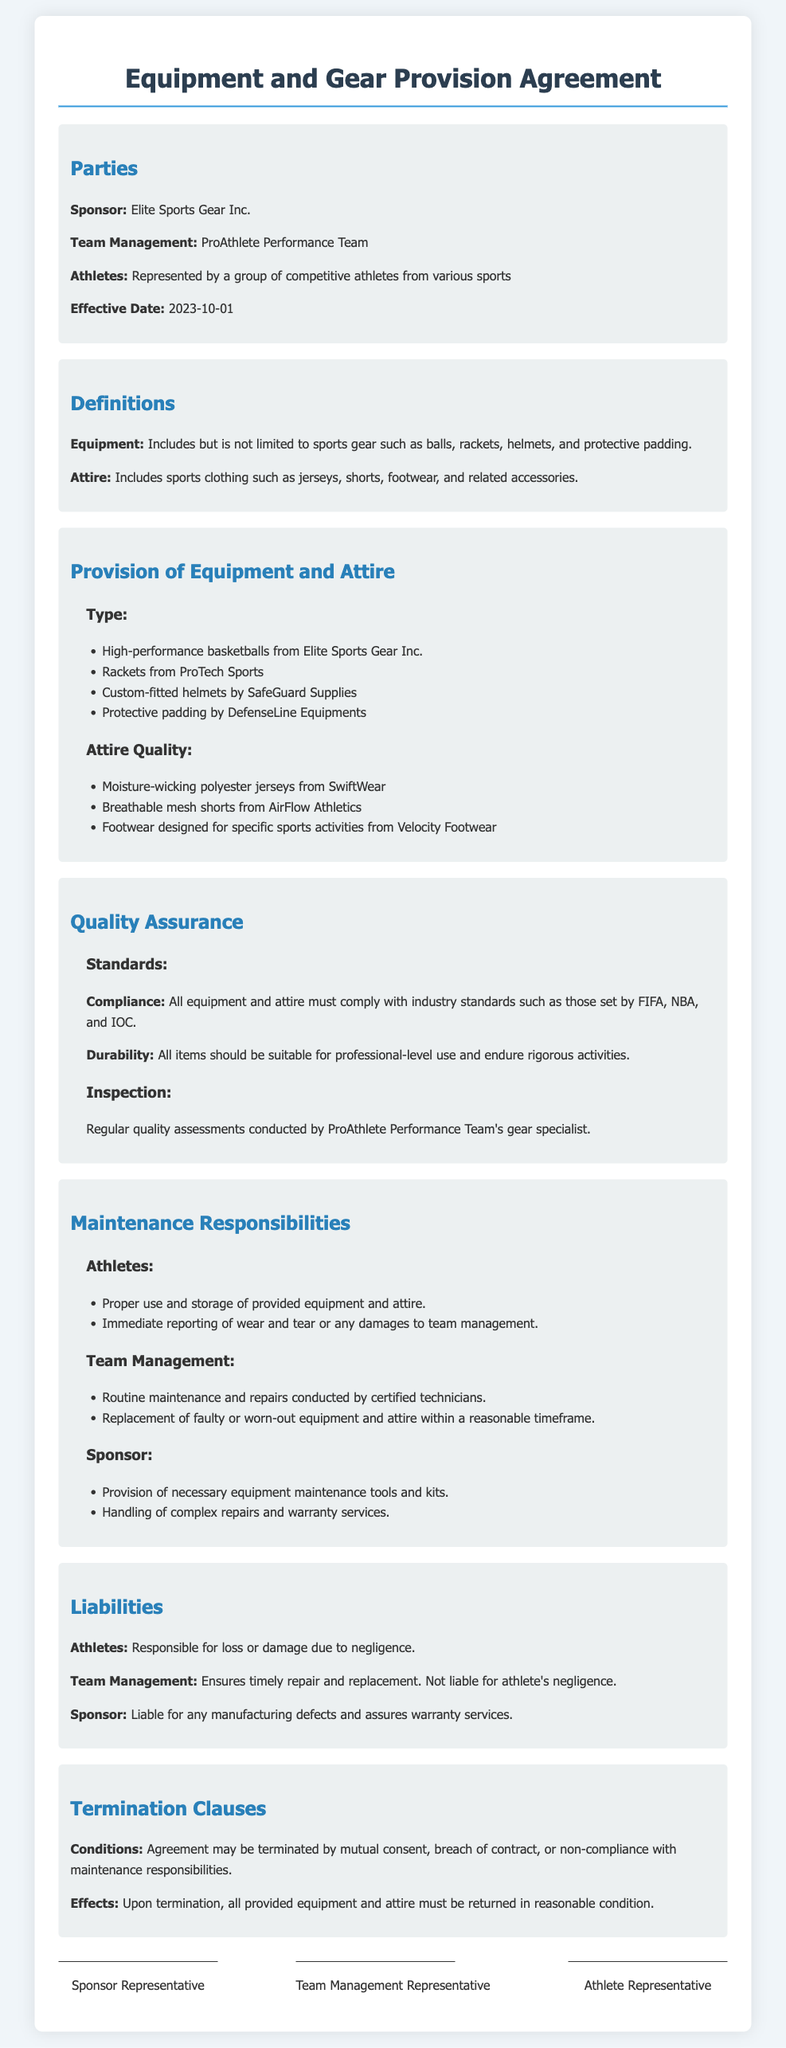What is the name of the sponsor? The name of the sponsor is mentioned in the Parties section of the document.
Answer: Elite Sports Gear Inc What date is the agreement effective from? The effective date is specified in the Parties section of the document.
Answer: 2023-10-01 What type of attire is included as per the document? The types of attire are listed in the Provision of Equipment and Attire section.
Answer: Jerseys, shorts, footwear What is the primary responsibility of athletes regarding equipment? The document specifies the responsibilities of athletes in the Maintenance Responsibilities section.
Answer: Proper use and storage Who is responsible for complex repairs? The obligations of the sponsor regarding repairs are mentioned in the Maintenance Responsibilities section.
Answer: Sponsor What must happen to the equipment upon termination of the agreement? The conditions regarding equipment return are detailed in the Termination Clauses section.
Answer: Returned in reasonable condition What standards must equipment and attire comply with? The requirements for compliance are listed under the Quality Assurance section.
Answer: Industry standards How often are quality assessments conducted? The inspection frequency is mentioned under the Inspection subsection of Quality Assurance.
Answer: Regularly 